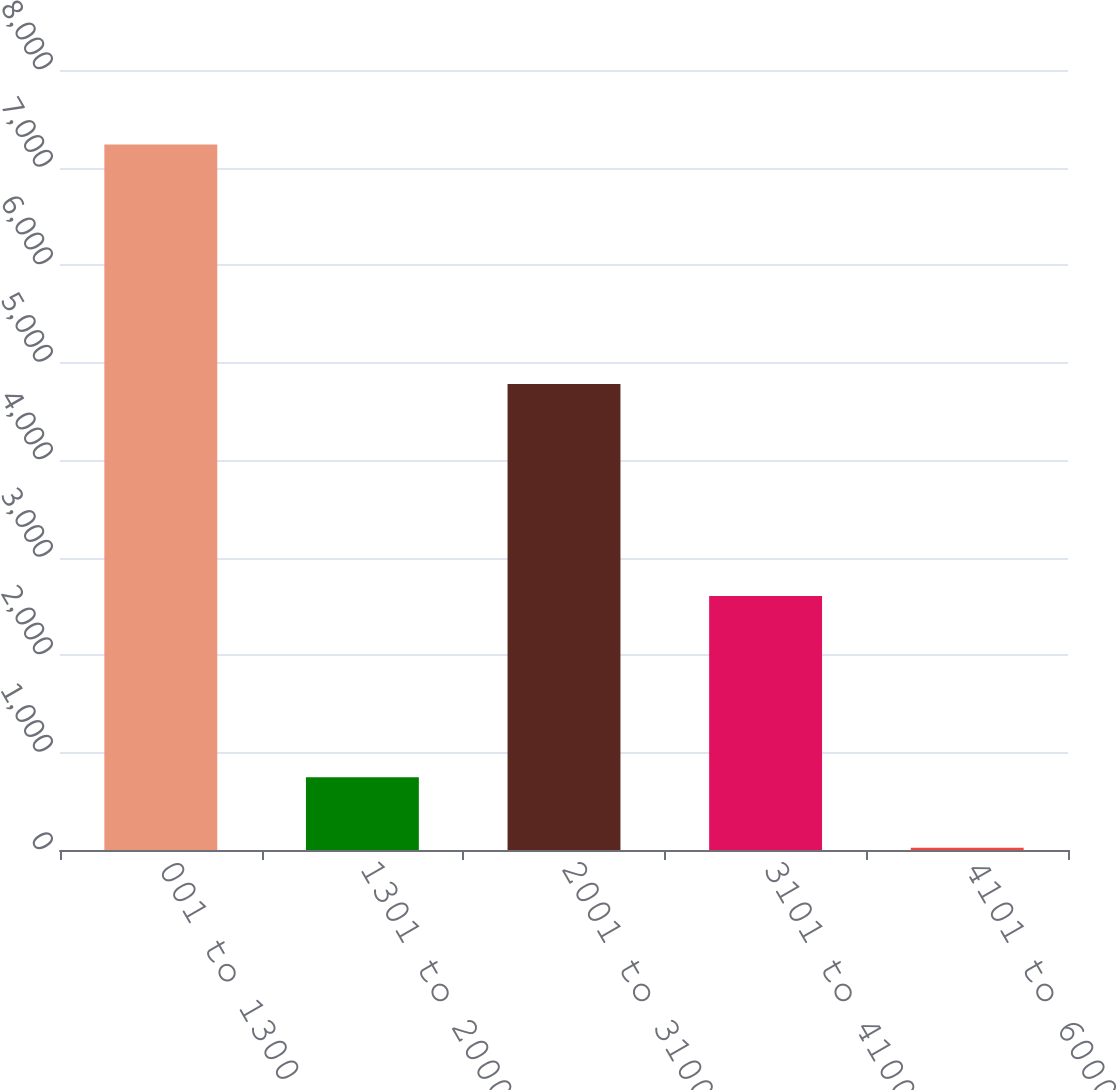Convert chart. <chart><loc_0><loc_0><loc_500><loc_500><bar_chart><fcel>001 to 1300<fcel>1301 to 2000<fcel>2001 to 3100<fcel>3101 to 4100<fcel>4101 to 6000<nl><fcel>7235<fcel>745.1<fcel>4780<fcel>2606<fcel>24<nl></chart> 